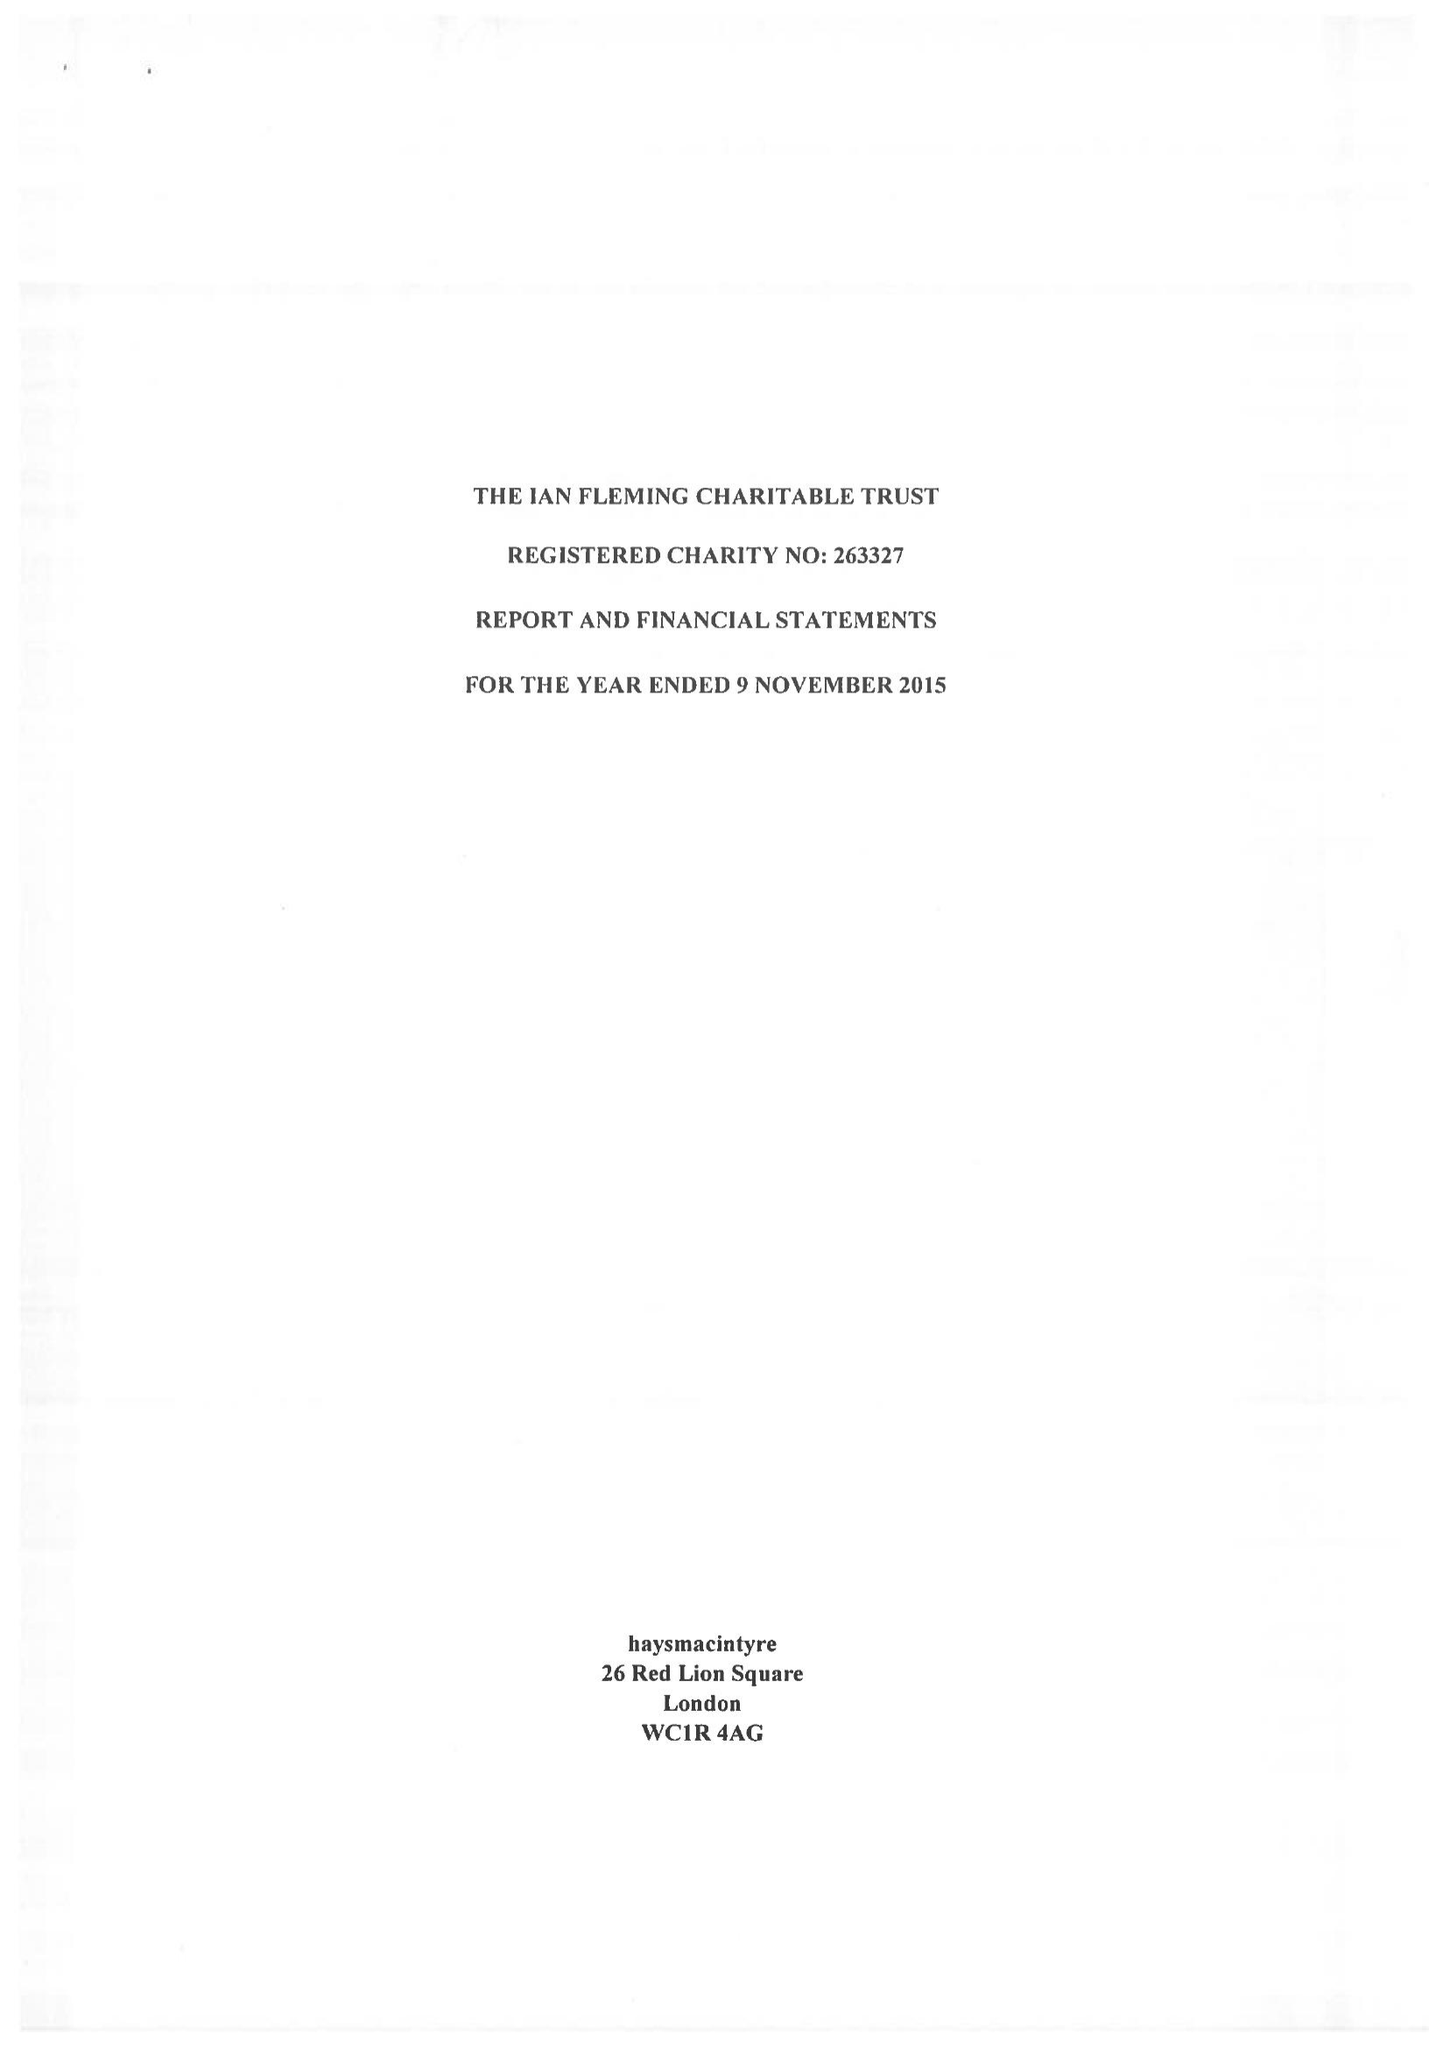What is the value for the income_annually_in_british_pounds?
Answer the question using a single word or phrase. 44755.00 